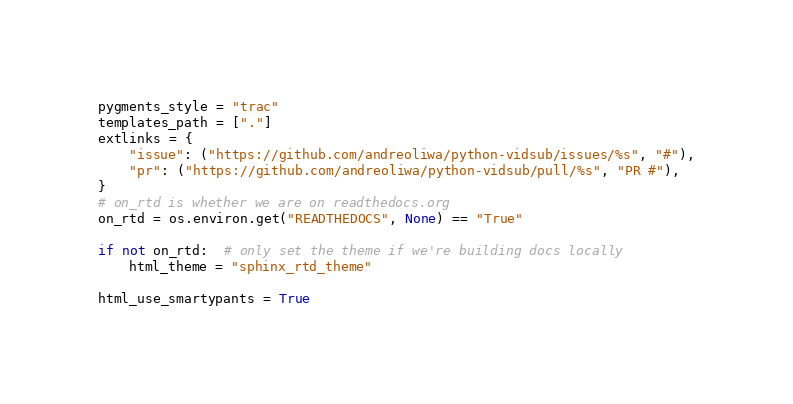<code> <loc_0><loc_0><loc_500><loc_500><_Python_>
pygments_style = "trac"
templates_path = ["."]
extlinks = {
    "issue": ("https://github.com/andreoliwa/python-vidsub/issues/%s", "#"),
    "pr": ("https://github.com/andreoliwa/python-vidsub/pull/%s", "PR #"),
}
# on_rtd is whether we are on readthedocs.org
on_rtd = os.environ.get("READTHEDOCS", None) == "True"

if not on_rtd:  # only set the theme if we're building docs locally
    html_theme = "sphinx_rtd_theme"

html_use_smartypants = True</code> 